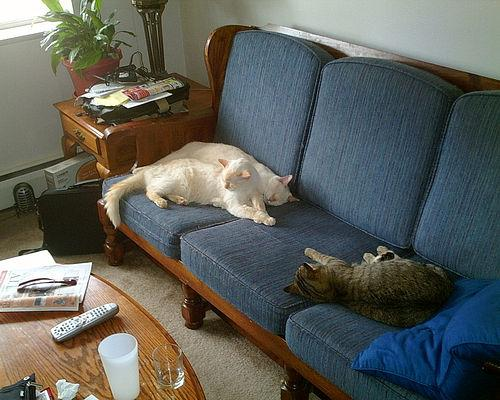What is the silver object on the table in front of the couch used to control? television 